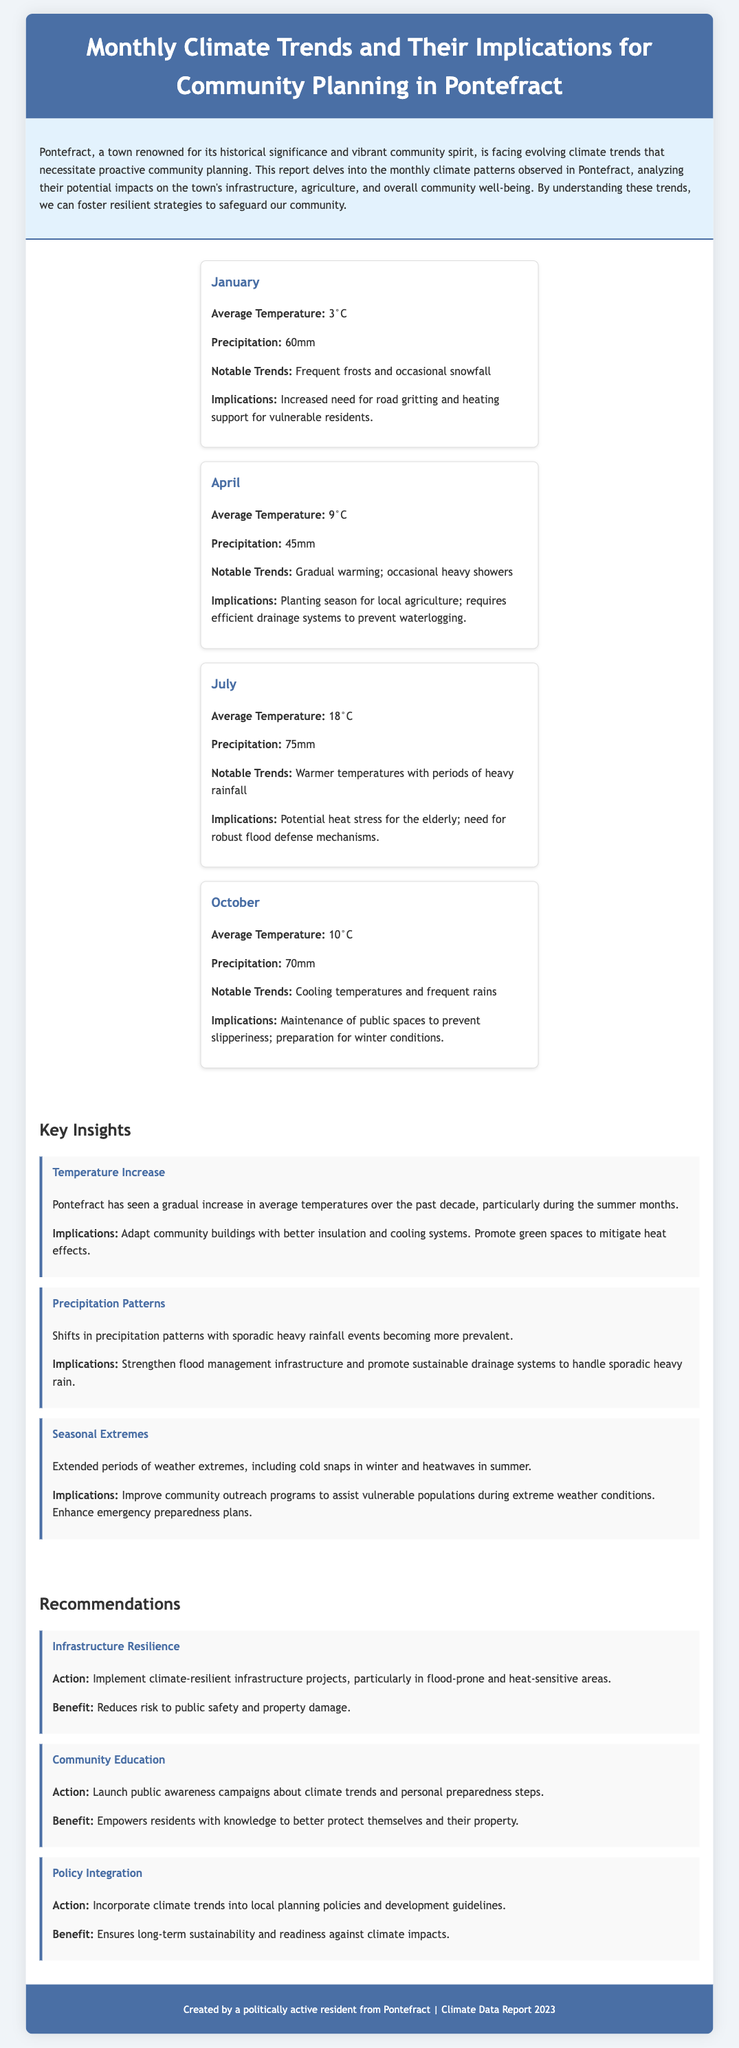What is the average temperature in January? January's average temperature is specifically listed in the document as 3°C.
Answer: 3°C What is the total precipitation in July? The document specifies that July has an average precipitation of 75mm.
Answer: 75mm What notable weather event occurs in April? The document mentions "occasional heavy showers" as notable trends in April.
Answer: Occasional heavy showers What is one implication of the increased average temperatures? The implications for increased temperatures include adapting community buildings with better insulation and cooling systems, as stated in the insights section.
Answer: Better insulation and cooling systems How many recommendation items are provided in the document? The document contains three distinct recommendations related to community planning and climate resilience.
Answer: Three What is one action suggested for improving community preparedness? The report recommends launching public awareness campaigns about climate trends, which empowers the residents.
Answer: Public awareness campaigns What was a notable trend in October? The document notes "Cooling temperatures and frequent rains" as a notable trend in October.
Answer: Cooling temperatures and frequent rains What is the average precipitation for October? October's average precipitation is clearly specified in the document as 70mm.
Answer: 70mm 